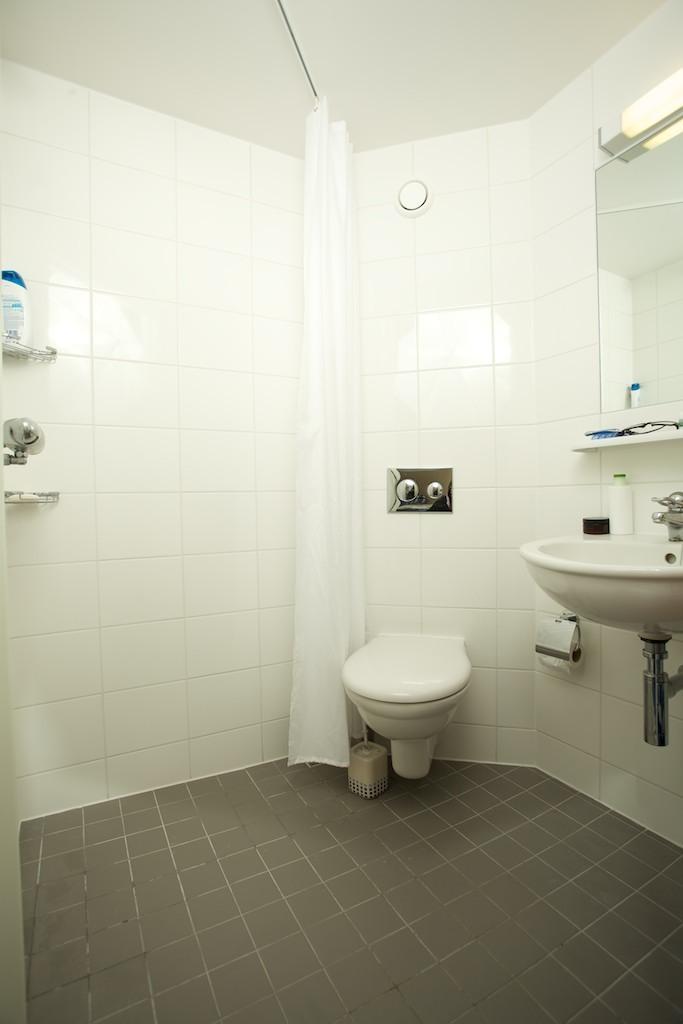Describe this image in one or two sentences. It is a washroom,there is a toilet seat. Beside the toilet seat there is a wash basin,in front of the wash basin there is a mirror and in the left side on the shelf there is a shampoo. In the background there is a wall made up of tiles. 